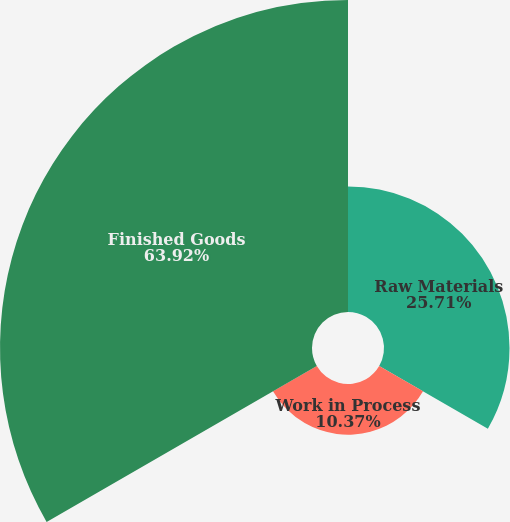Convert chart to OTSL. <chart><loc_0><loc_0><loc_500><loc_500><pie_chart><fcel>Raw Materials<fcel>Work in Process<fcel>Finished Goods<nl><fcel>25.71%<fcel>10.37%<fcel>63.91%<nl></chart> 